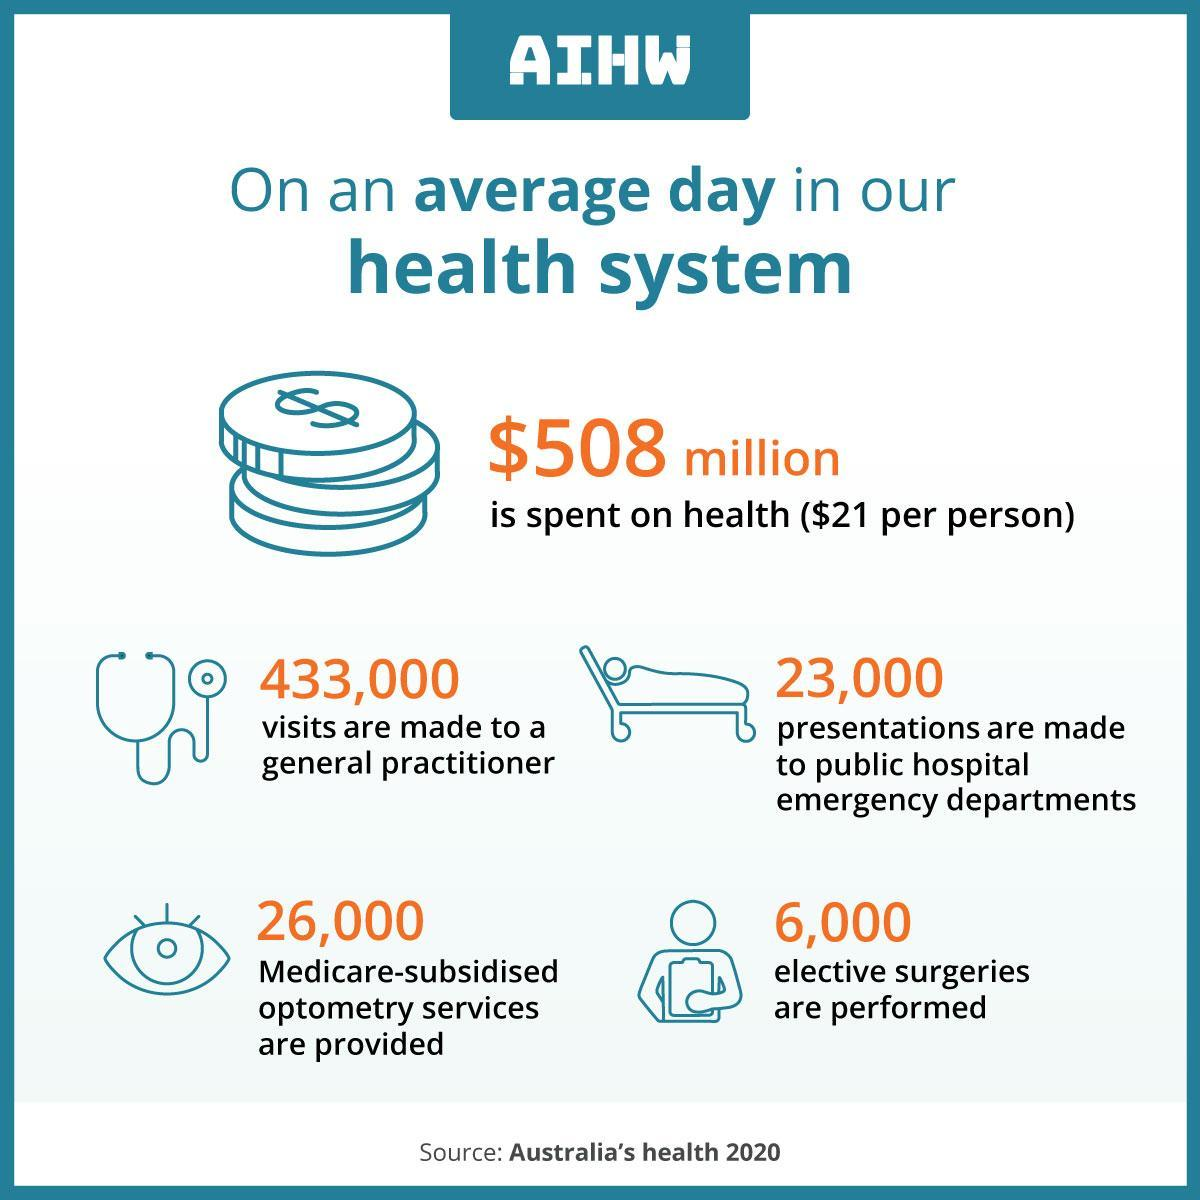How many elective surgeries are performed on an average day in AIHW?
Answer the question with a short phrase. 6,000 How many visits are made to a general practitioner on an average day in AIHW? 433,000 